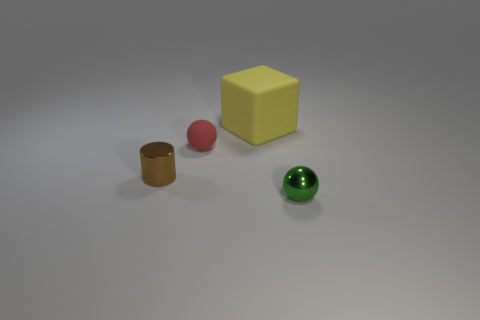Add 1 tiny yellow shiny cylinders. How many objects exist? 5 Subtract all green spheres. How many spheres are left? 1 Subtract all blocks. How many objects are left? 3 Subtract all gray blocks. Subtract all blue cylinders. How many blocks are left? 1 Subtract all tiny brown objects. Subtract all small green objects. How many objects are left? 2 Add 4 small matte objects. How many small matte objects are left? 5 Add 2 tiny purple blocks. How many tiny purple blocks exist? 2 Subtract 1 brown cylinders. How many objects are left? 3 